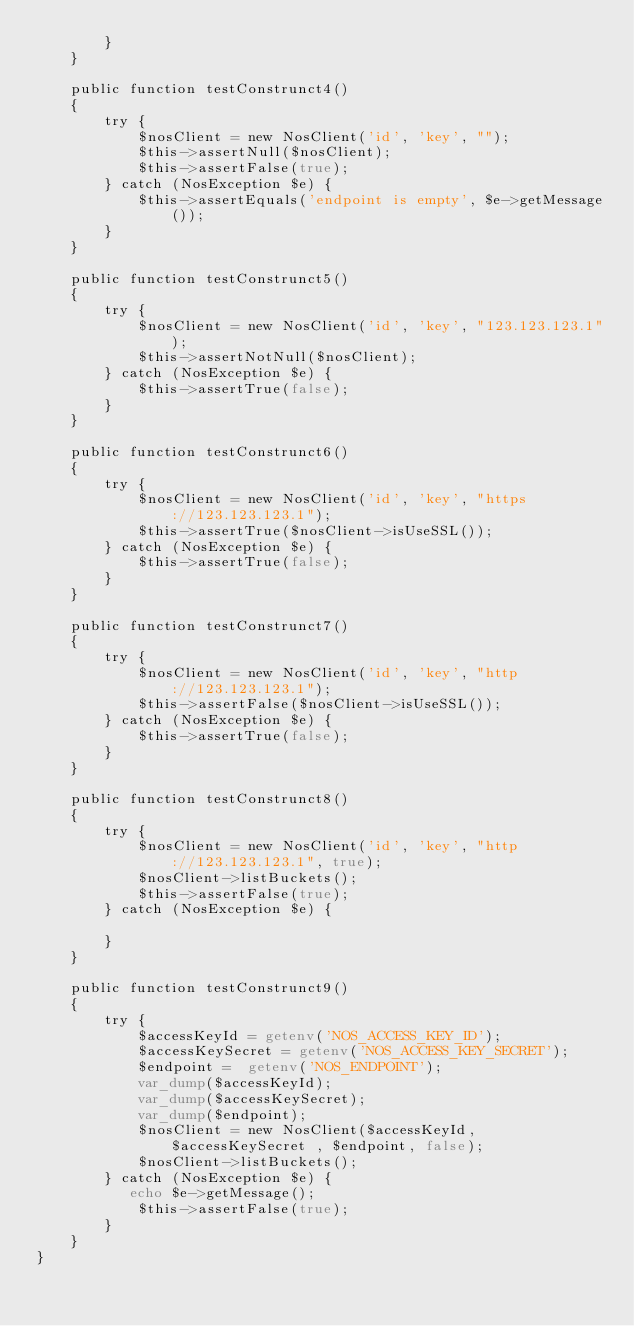Convert code to text. <code><loc_0><loc_0><loc_500><loc_500><_PHP_>        }
    }

    public function testConstrunct4()
    {
        try {
            $nosClient = new NosClient('id', 'key', "");
            $this->assertNull($nosClient);
            $this->assertFalse(true);
        } catch (NosException $e) {
            $this->assertEquals('endpoint is empty', $e->getMessage());
        }
    }

    public function testConstrunct5()
    {
        try {
            $nosClient = new NosClient('id', 'key', "123.123.123.1");
            $this->assertNotNull($nosClient);
        } catch (NosException $e) {
            $this->assertTrue(false);
        }
    }

    public function testConstrunct6()
    {
        try {
            $nosClient = new NosClient('id', 'key', "https://123.123.123.1");
            $this->assertTrue($nosClient->isUseSSL());
        } catch (NosException $e) {
            $this->assertTrue(false);
        }
    }

    public function testConstrunct7()
    {
        try {
            $nosClient = new NosClient('id', 'key', "http://123.123.123.1");
            $this->assertFalse($nosClient->isUseSSL());
        } catch (NosException $e) {
            $this->assertTrue(false);
        }
    }

    public function testConstrunct8()
    {
        try {
            $nosClient = new NosClient('id', 'key', "http://123.123.123.1", true);
            $nosClient->listBuckets();
            $this->assertFalse(true);
        } catch (NosException $e) {

        }
    }

    public function testConstrunct9()
    {
        try {
            $accessKeyId = getenv('NOS_ACCESS_KEY_ID');
            $accessKeySecret = getenv('NOS_ACCESS_KEY_SECRET');
            $endpoint =  getenv('NOS_ENDPOINT');
            var_dump($accessKeyId);
            var_dump($accessKeySecret);
            var_dump($endpoint);
            $nosClient = new NosClient($accessKeyId, $accessKeySecret , $endpoint, false);
            $nosClient->listBuckets();
        } catch (NosException $e) {
           echo $e->getMessage();
            $this->assertFalse(true);
        }
    }
}

</code> 